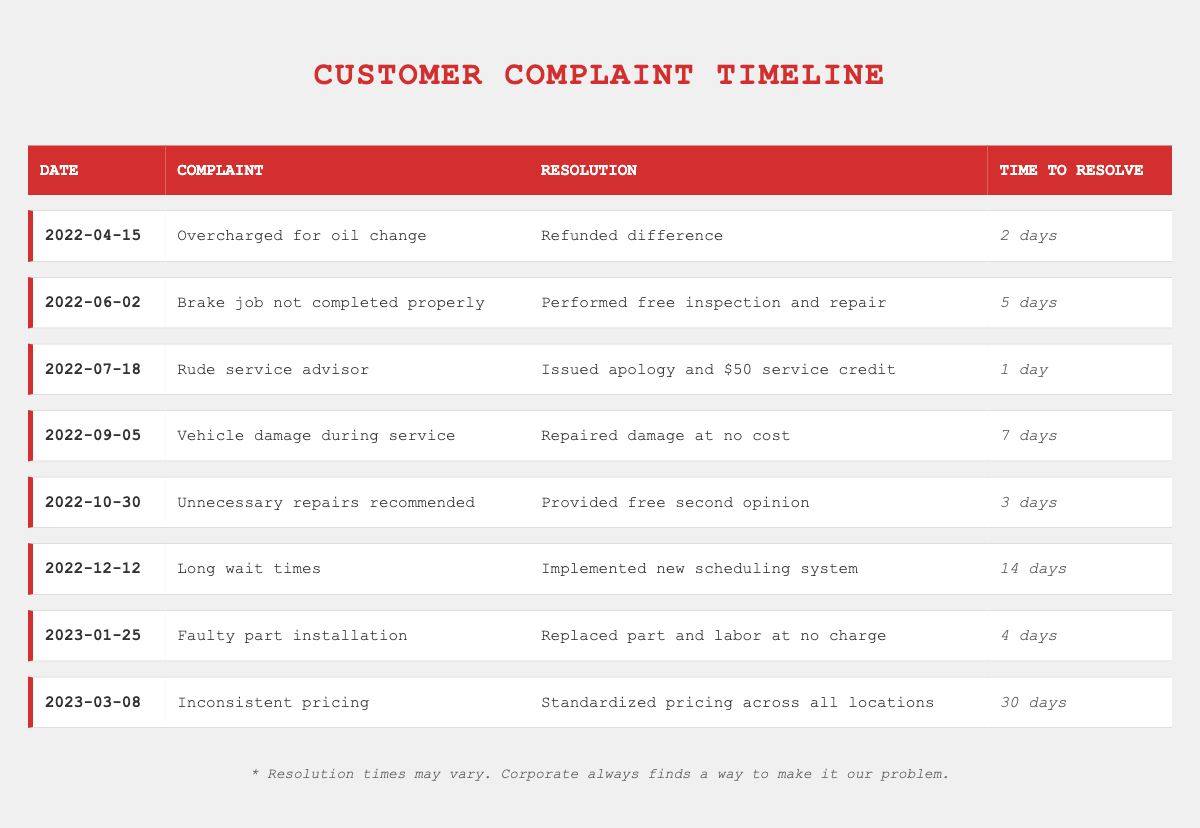What was the resolution for the complaint about being overcharged for an oil change? The resolution for the complaint on April 15, 2022, regarding being overcharged for an oil change was to refund the difference. This is directly referenced in the table under the resolution column for that date.
Answer: Refunded difference How long did it take to resolve the complaint about rude service? The complaint regarding rude service on July 18, 2022, was resolved in 1 day, as stated clearly in the resolution time column for that entry.
Answer: 1 day What was the longest resolution time recorded? The longest resolution time can be found by looking at the resolution times in the table. The largest number is 30 days for the complaint about inconsistent pricing on March 8, 2023.
Answer: 30 days Did a customer receive a service credit for a complaint? Yes, on July 18, 2022, a customer received a $50 service credit as a resolution for their complaint about a rude service advisor. This is stated in the resolution column for that date.
Answer: Yes What is the average resolution time for complaints made in 2022? To find the average resolution time for complaints in 2022, we first sum the resolution times for all complaints in that year: 2 + 5 + 1 + 7 + 3 + 14 = 32 days. There are 6 complaints, so the average is 32 days divided by 6, which equals approximately 5.33 days.
Answer: 5.33 days How many complaints had resolutions implemented within a week? By reviewing the timeline, resolutions that were completed in 7 days or less include the complaints on April 15 (2 days), June 2 (5 days), July 18 (1 day), and October 30 (3 days). Therefore, 4 complaints were resolved within a week.
Answer: 4 complaints What measures were taken to reduce long wait times? A new scheduling system was implemented as a measure to reduce long wait times, as stated in the resolution for the complaint recorded on December 12, 2022. This indicates a proactive change in response to customer feedback.
Answer: Implemented new scheduling system Which complaint had the fastest resolution time and what was it? The fastest resolution time was 1 day for the complaint about rude service on July 18, 2022. This is the minimum resolution time listed in the table, highlighting quick action taken for this issue.
Answer: 1 day Which customer complaint involved repair work and what was the outcome? The complaint about vehicle damage during service is the one that involved repair work. The resolution for this complaint, recorded on September 5, 2022, was that the damage was repaired at no cost.
Answer: Repaired damage at no cost 